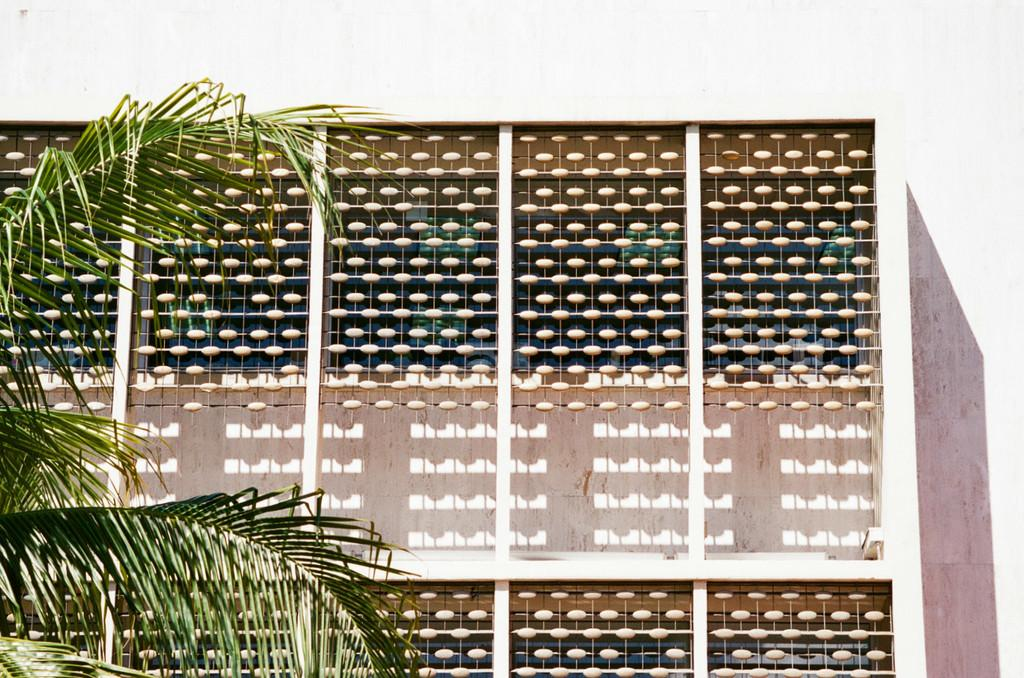What type of structure is visible in the image? There is a building in the image. What architectural features can be seen in the image? There are walls and a grille visible in the image. What type of objects are made of glass in the image? There are glass objects in the image. Where is the tree located in the image? The tree is on the left side of the image. What type of jeans is the person wearing on the right side of the image? There is no person or jeans present in the image. 